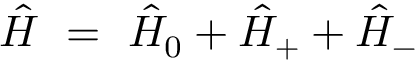<formula> <loc_0><loc_0><loc_500><loc_500>\hat { H } = \hat { H } _ { 0 } + \hat { H } _ { + } + \hat { H } _ { - }</formula> 